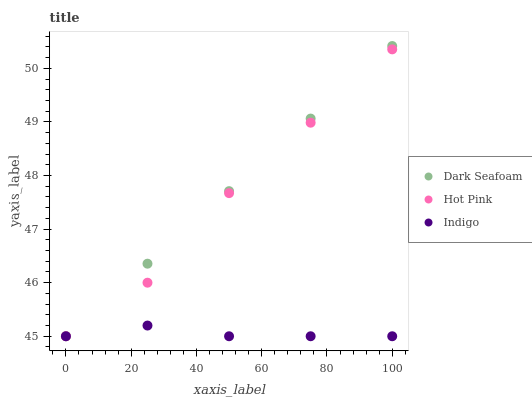Does Indigo have the minimum area under the curve?
Answer yes or no. Yes. Does Dark Seafoam have the maximum area under the curve?
Answer yes or no. Yes. Does Hot Pink have the minimum area under the curve?
Answer yes or no. No. Does Hot Pink have the maximum area under the curve?
Answer yes or no. No. Is Dark Seafoam the smoothest?
Answer yes or no. Yes. Is Hot Pink the roughest?
Answer yes or no. Yes. Is Indigo the smoothest?
Answer yes or no. No. Is Indigo the roughest?
Answer yes or no. No. Does Dark Seafoam have the lowest value?
Answer yes or no. Yes. Does Dark Seafoam have the highest value?
Answer yes or no. Yes. Does Hot Pink have the highest value?
Answer yes or no. No. Does Hot Pink intersect Dark Seafoam?
Answer yes or no. Yes. Is Hot Pink less than Dark Seafoam?
Answer yes or no. No. Is Hot Pink greater than Dark Seafoam?
Answer yes or no. No. 